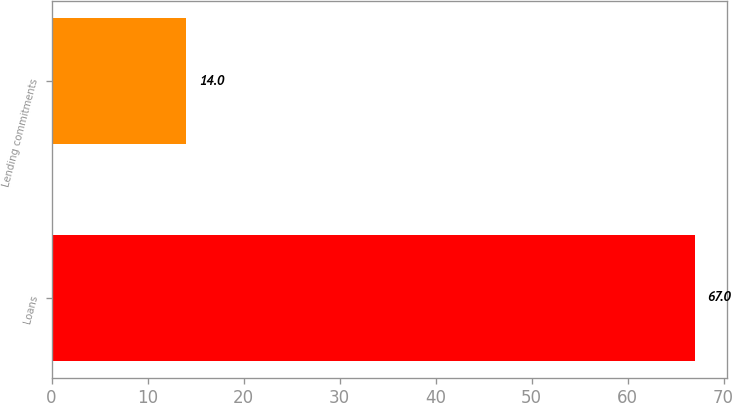Convert chart to OTSL. <chart><loc_0><loc_0><loc_500><loc_500><bar_chart><fcel>Loans<fcel>Lending commitments<nl><fcel>67<fcel>14<nl></chart> 